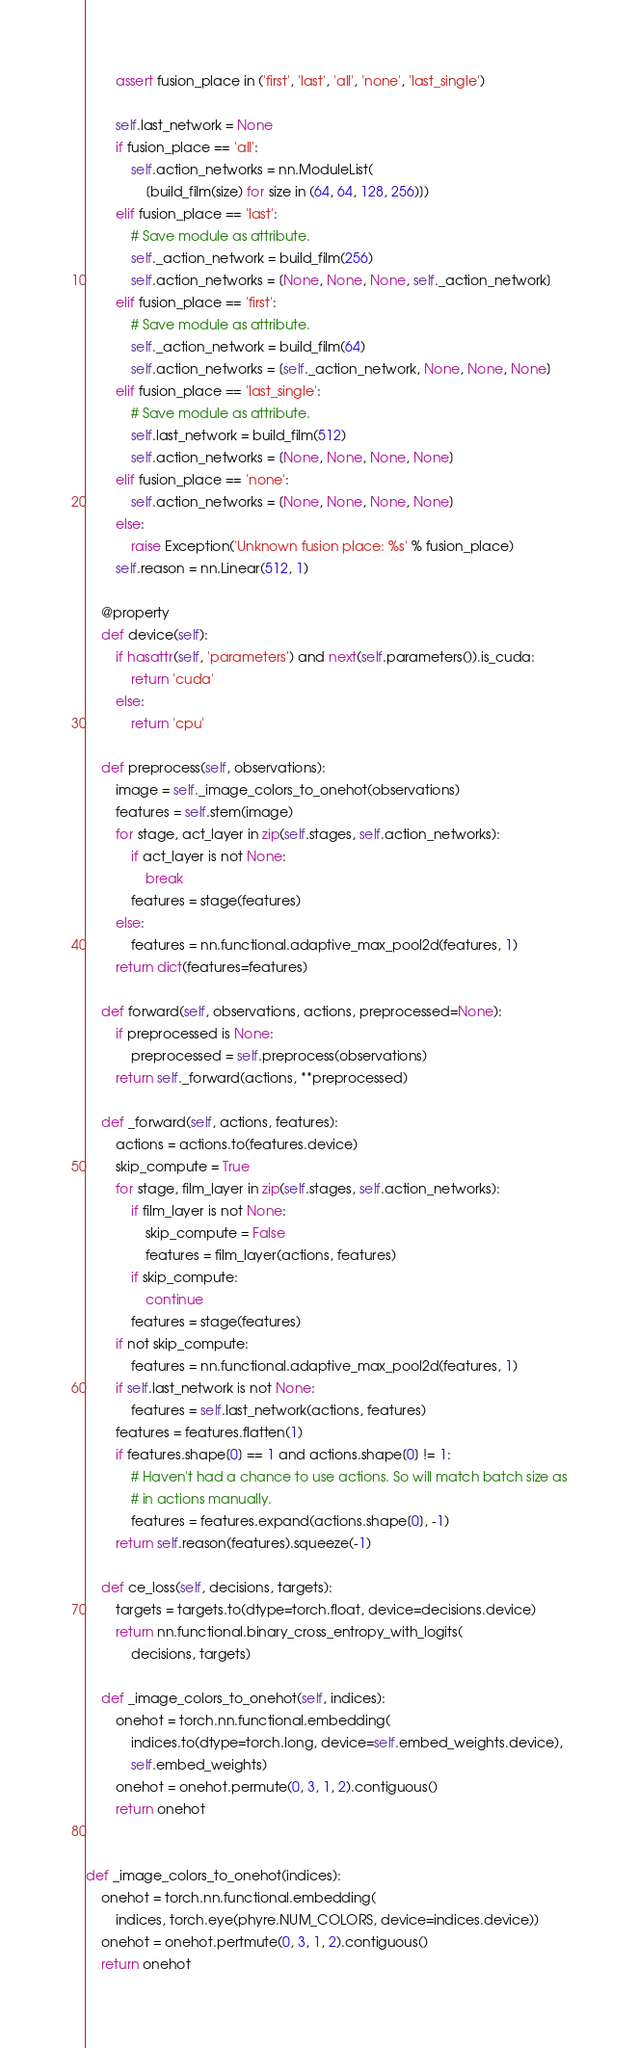Convert code to text. <code><loc_0><loc_0><loc_500><loc_500><_Python_>        assert fusion_place in ('first', 'last', 'all', 'none', 'last_single')

        self.last_network = None
        if fusion_place == 'all':
            self.action_networks = nn.ModuleList(
                [build_film(size) for size in (64, 64, 128, 256)])
        elif fusion_place == 'last':
            # Save module as attribute.
            self._action_network = build_film(256)
            self.action_networks = [None, None, None, self._action_network]
        elif fusion_place == 'first':
            # Save module as attribute.
            self._action_network = build_film(64)
            self.action_networks = [self._action_network, None, None, None]
        elif fusion_place == 'last_single':
            # Save module as attribute.
            self.last_network = build_film(512)
            self.action_networks = [None, None, None, None]
        elif fusion_place == 'none':
            self.action_networks = [None, None, None, None]
        else:
            raise Exception('Unknown fusion place: %s' % fusion_place)
        self.reason = nn.Linear(512, 1)

    @property
    def device(self):
        if hasattr(self, 'parameters') and next(self.parameters()).is_cuda:
            return 'cuda'
        else:
            return 'cpu'

    def preprocess(self, observations):
        image = self._image_colors_to_onehot(observations)
        features = self.stem(image)
        for stage, act_layer in zip(self.stages, self.action_networks):
            if act_layer is not None:
                break
            features = stage(features)
        else:
            features = nn.functional.adaptive_max_pool2d(features, 1)
        return dict(features=features)

    def forward(self, observations, actions, preprocessed=None):
        if preprocessed is None:
            preprocessed = self.preprocess(observations)
        return self._forward(actions, **preprocessed)

    def _forward(self, actions, features):
        actions = actions.to(features.device)
        skip_compute = True
        for stage, film_layer in zip(self.stages, self.action_networks):
            if film_layer is not None:
                skip_compute = False
                features = film_layer(actions, features)
            if skip_compute:
                continue
            features = stage(features)
        if not skip_compute:
            features = nn.functional.adaptive_max_pool2d(features, 1)
        if self.last_network is not None:
            features = self.last_network(actions, features)
        features = features.flatten(1)
        if features.shape[0] == 1 and actions.shape[0] != 1:
            # Haven't had a chance to use actions. So will match batch size as
            # in actions manually.
            features = features.expand(actions.shape[0], -1)
        return self.reason(features).squeeze(-1)

    def ce_loss(self, decisions, targets):
        targets = targets.to(dtype=torch.float, device=decisions.device)
        return nn.functional.binary_cross_entropy_with_logits(
            decisions, targets)

    def _image_colors_to_onehot(self, indices):
        onehot = torch.nn.functional.embedding(
            indices.to(dtype=torch.long, device=self.embed_weights.device),
            self.embed_weights)
        onehot = onehot.permute(0, 3, 1, 2).contiguous()
        return onehot


def _image_colors_to_onehot(indices):
    onehot = torch.nn.functional.embedding(
        indices, torch.eye(phyre.NUM_COLORS, device=indices.device))
    onehot = onehot.pertmute(0, 3, 1, 2).contiguous()
    return onehot
</code> 